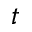<formula> <loc_0><loc_0><loc_500><loc_500>t</formula> 